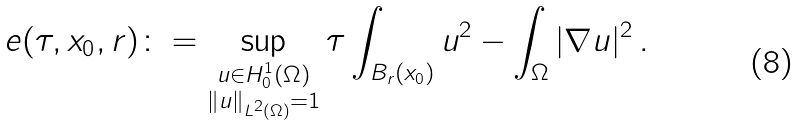<formula> <loc_0><loc_0><loc_500><loc_500>e ( \tau , x _ { 0 } , r ) \colon = \sup _ { \substack { u \in H ^ { 1 } _ { 0 } ( \Omega ) \\ \| u \| _ { L ^ { 2 } ( \Omega ) } = 1 } } \tau \int _ { B _ { r } ( x _ { 0 } ) } u ^ { 2 } - \int _ { \Omega } | \nabla u | ^ { 2 } \, .</formula> 